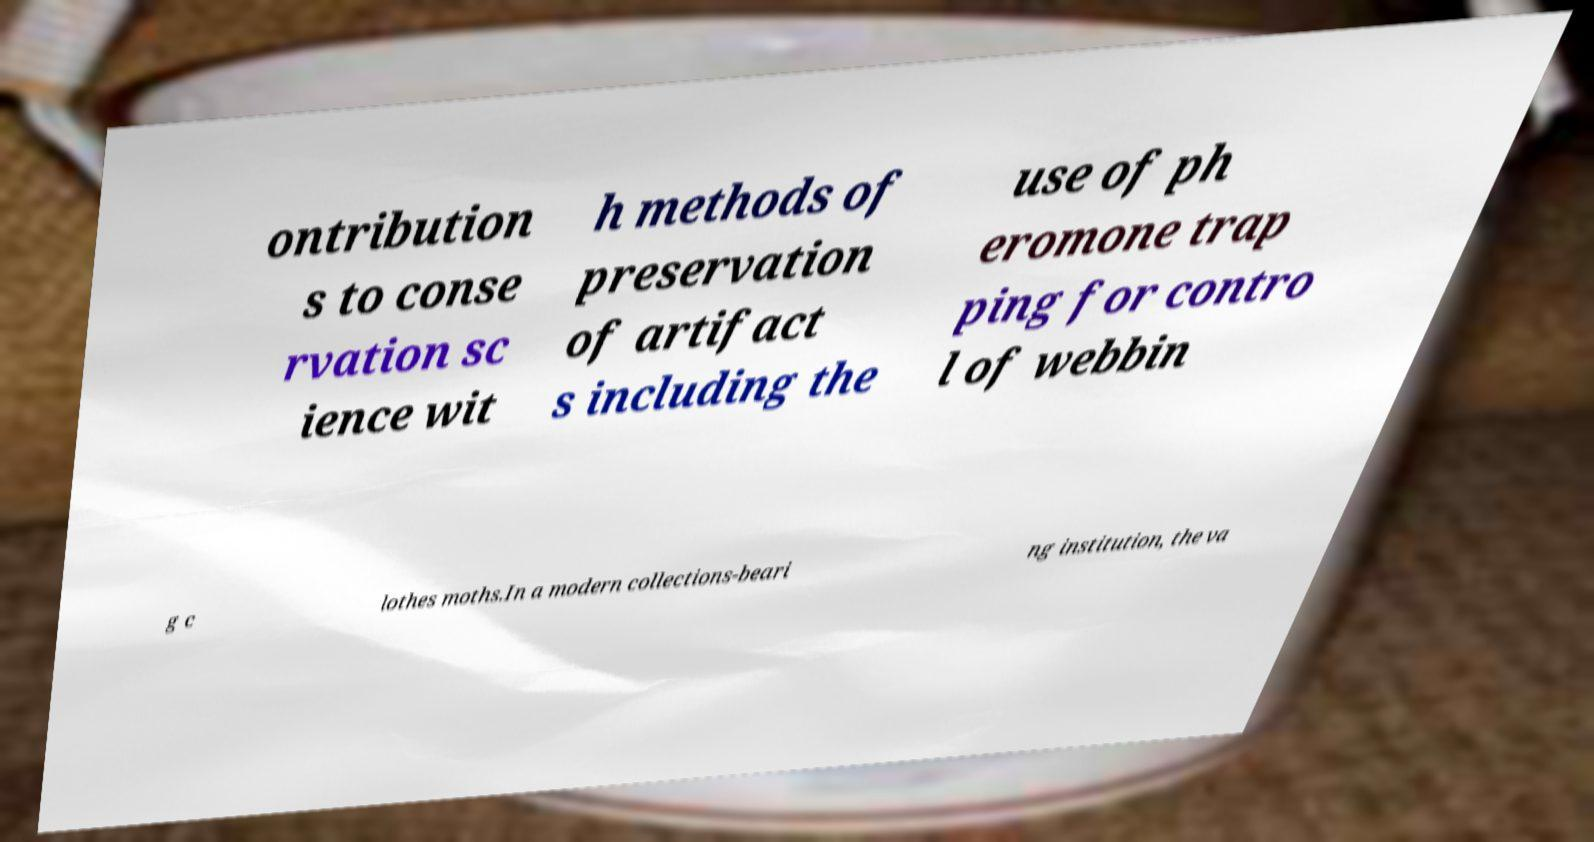Could you assist in decoding the text presented in this image and type it out clearly? ontribution s to conse rvation sc ience wit h methods of preservation of artifact s including the use of ph eromone trap ping for contro l of webbin g c lothes moths.In a modern collections-beari ng institution, the va 